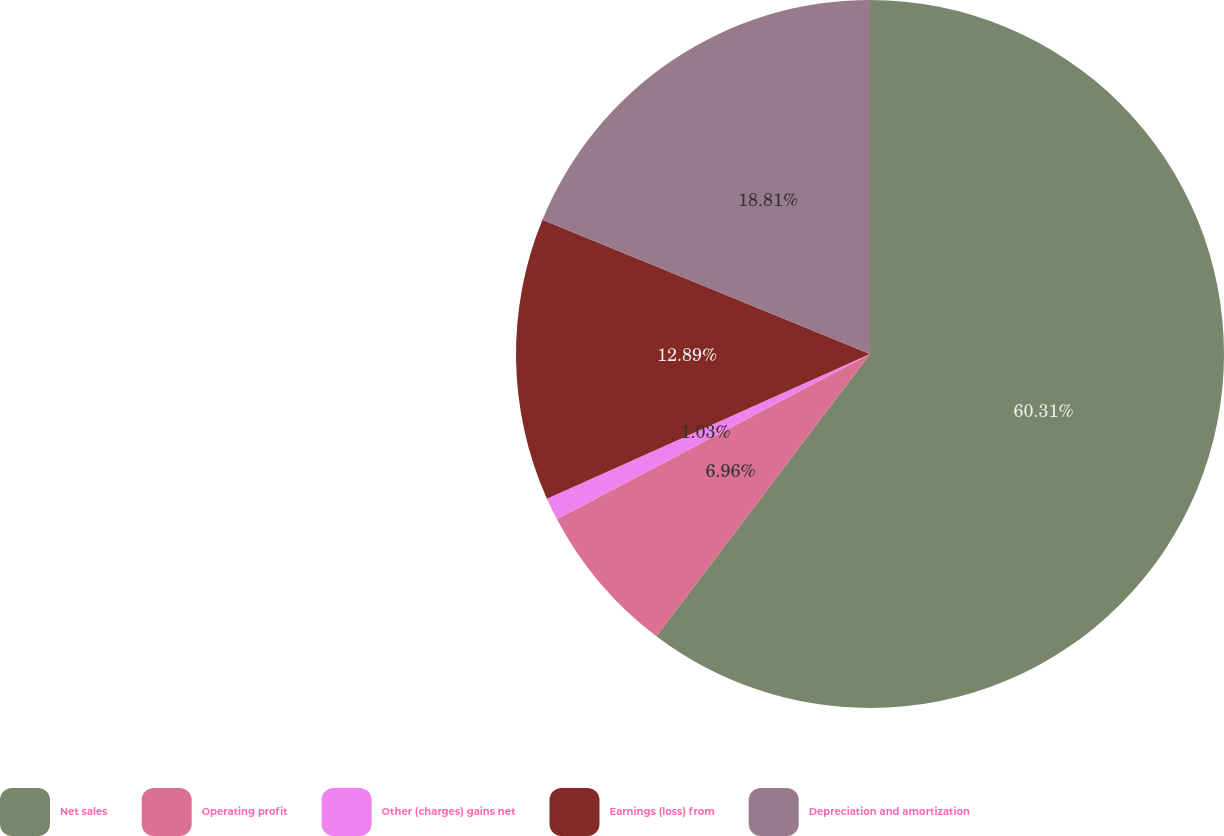<chart> <loc_0><loc_0><loc_500><loc_500><pie_chart><fcel>Net sales<fcel>Operating profit<fcel>Other (charges) gains net<fcel>Earnings (loss) from<fcel>Depreciation and amortization<nl><fcel>60.31%<fcel>6.96%<fcel>1.03%<fcel>12.89%<fcel>18.81%<nl></chart> 